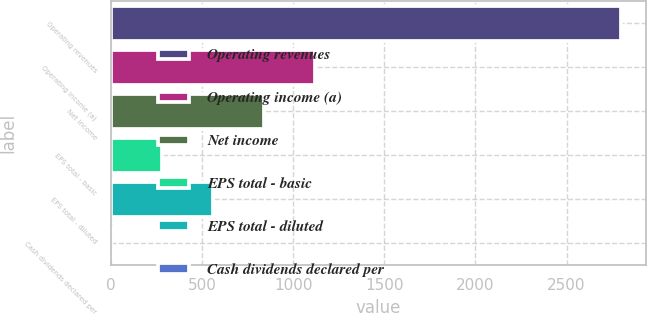Convert chart. <chart><loc_0><loc_0><loc_500><loc_500><bar_chart><fcel>Operating revenues<fcel>Operating income (a)<fcel>Net income<fcel>EPS total - basic<fcel>EPS total - diluted<fcel>Cash dividends declared per<nl><fcel>2796<fcel>1118.6<fcel>839.04<fcel>279.92<fcel>559.48<fcel>0.36<nl></chart> 